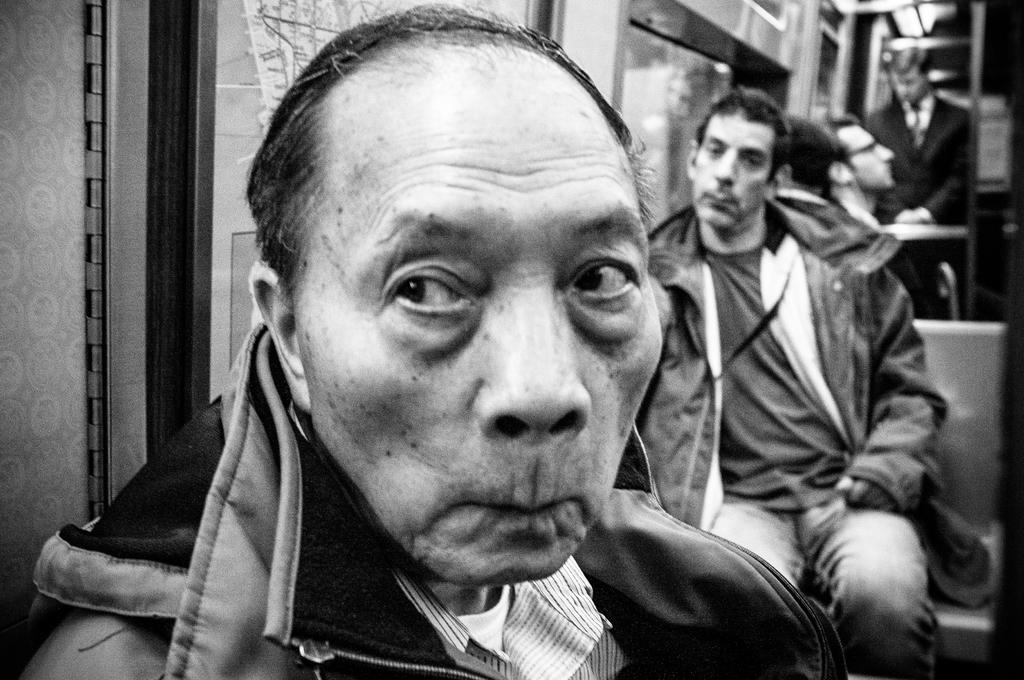What are the people in the image wearing? The people in the image are wearing jackets. What can be seen in the background of the image? The background of the image includes seats. What color scheme is used in the image? The image is in black and white color. What type of lettuce is visible on the sheet in the image? There is no sheet or lettuce present in the image. What color is the ink used to write on the people's jackets in the image? There is no writing or ink visible on the people's jackets in the image, as it is in black and white color. 